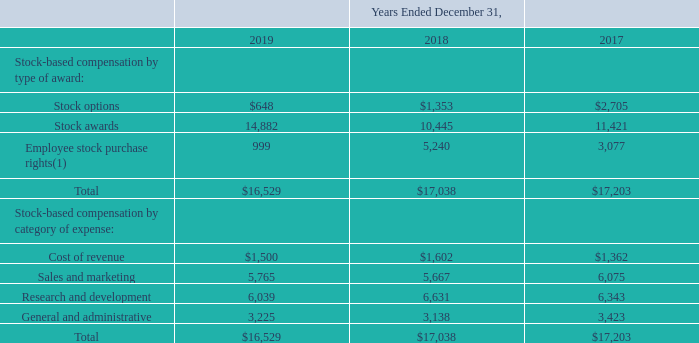Stock-Based Compensation
A summary of our stock-based compensation expense is as follows (in thousands):
(1) Amount for the year ended December 31, 2018 includes $4.1 million of accelerated stock-based compensation expense. In March 2018, as
a result of a suspension of the 2014 Purchase Plan due to our non-timely filing status, all unrecognized stock-based compensation expense
related to ESPP under the 2014 Purchase Plan was accelerated and recognized within the consolidated statement of operations.
As of December 31, 2019, we had $29.5 million of unrecognized stock-based compensation expense related to
unvested stock-based awards, including ESPP under our Amended 2014 Purchase Plan, which will be recognized
over a weighted-average period of 2.6 years.
What is the amount of employee stock purchase rights including accelerated stock-based compensation expense at the end of 2019?
Answer scale should be: thousand. 999. What is the amount of employee stock purchase rights including accelerated stock-based compensation expense at the end of 2018?
Answer scale should be: thousand. 5,240. What is the amount of employee stock purchase rights including accelerated stock-based compensation expense at the end of 2017?
Answer scale should be: thousand. 3,077. What is the percentage change in total stock base compensation  by type of award between 2018 and 2019?
Answer scale should be: percent. (16,529 - 17,038)/17,038 
Answer: -2.99. What is the total stock based compensation amount between 2017 to 2019?
Answer scale should be: thousand. $16,529 + $17,038 + $17,203
Answer: 50770. What is the percentage change in stock based compensation on sales and marketing between 2018 and 2019?
Answer scale should be: percent. (5,765 - 5,667)/5,667 
Answer: 1.73. 